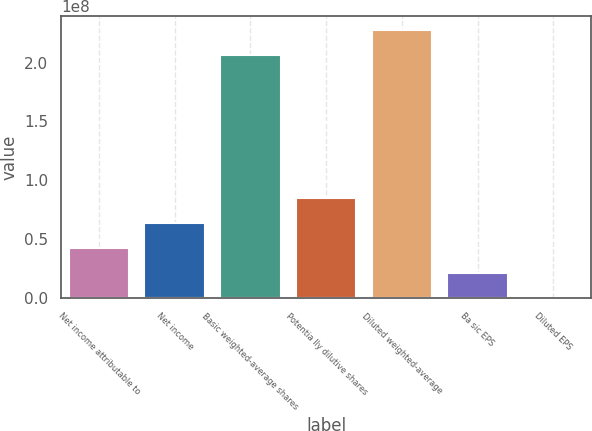<chart> <loc_0><loc_0><loc_500><loc_500><bar_chart><fcel>Net income attributable to<fcel>Net income<fcel>Basic weighted-average shares<fcel>Potentia lly dilutive shares<fcel>Diluted weighted-average<fcel>Ba sic EPS<fcel>Diluted EPS<nl><fcel>4.24036e+07<fcel>6.36053e+07<fcel>2.06525e+08<fcel>8.48071e+07<fcel>2.27727e+08<fcel>2.12018e+07<fcel>1.62<nl></chart> 